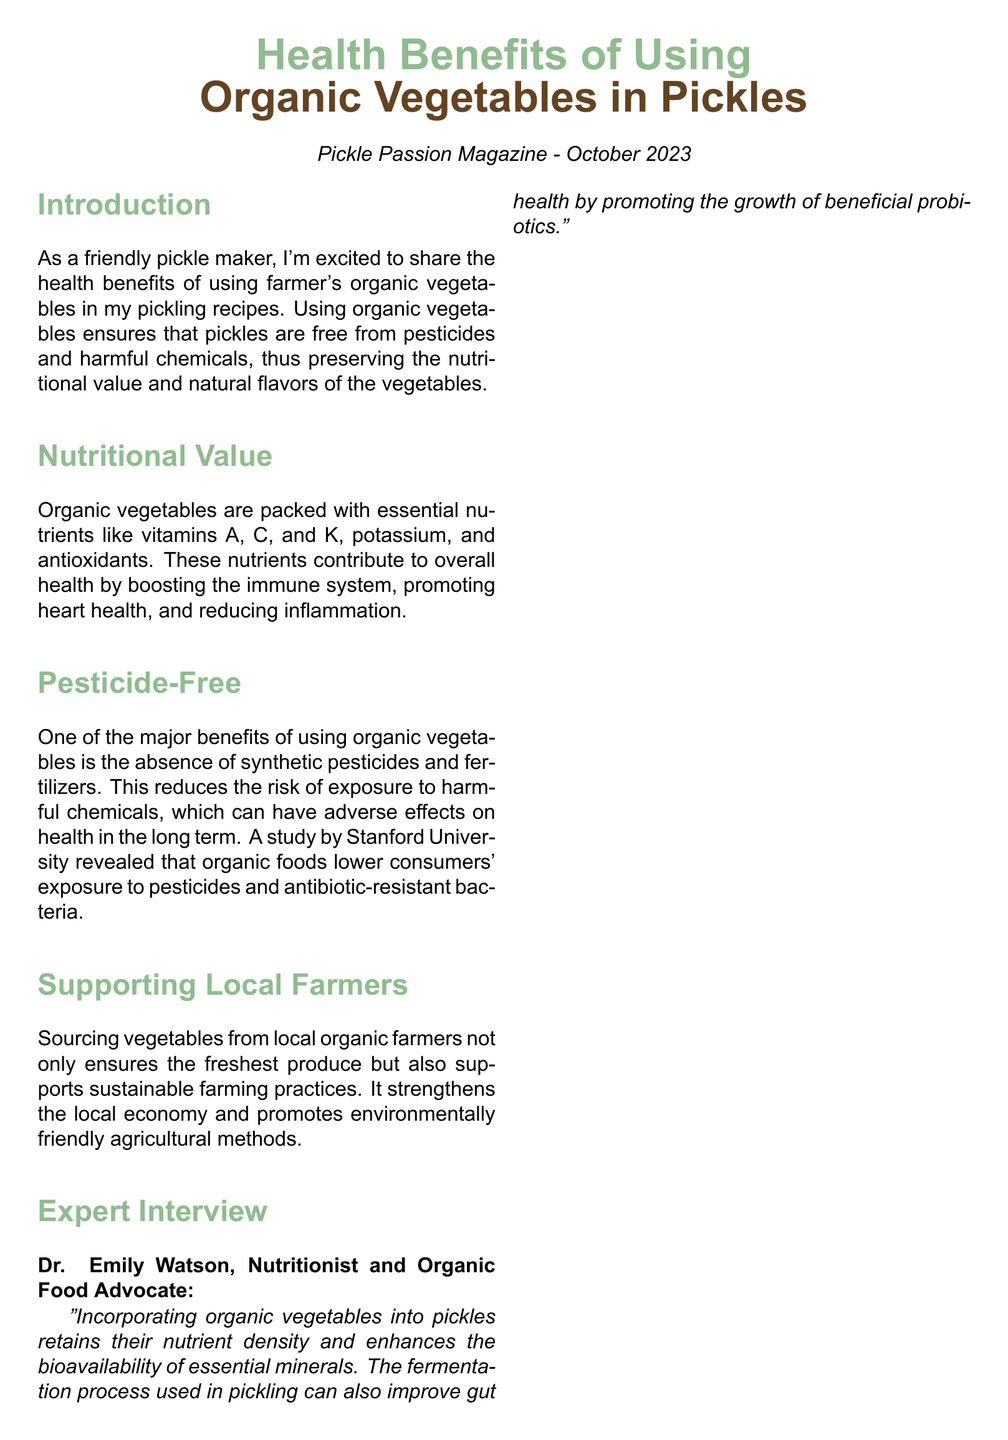what is the magazine's title? The title of the magazine appears at the top of the document, identified as "Pickle Passion Magazine".
Answer: Pickle Passion Magazine what is the publication date? The publication date is noted in the header of the document as October 2023.
Answer: October 2023 who is interviewed in the document? The interview includes insights from a nutritionist, and their name is specified in the document.
Answer: Dr. Emily Watson what are the health benefits related to organic vegetables mentioned? The document lists several benefits of using organic vegetables in pickles, which include the absence of pesticides and nutritional advantages.
Answer: Pesticide-free, Rich in nutrients, Supports local farmers, Promotes gut health, Environmentally friendly which study is referenced in the article? A specific study that highlights the advantages of organic foods is mentioned in the document; the source of this research is an institution.
Answer: Stanford University what is one key nutrient found in organic vegetables? The article highlights several nutrients, and a specific example is asked for in this case.
Answer: Vitamin C how do organic vegetables support local farming? The document explains a broader impact of using organic vegetables in support of economic practices.
Answer: Supports sustainable farming practices how does pickling affect gut health? The article mentions the fermentation process tied to pickling and reflects its outcome on health.
Answer: Promoting the growth of beneficial probiotics 